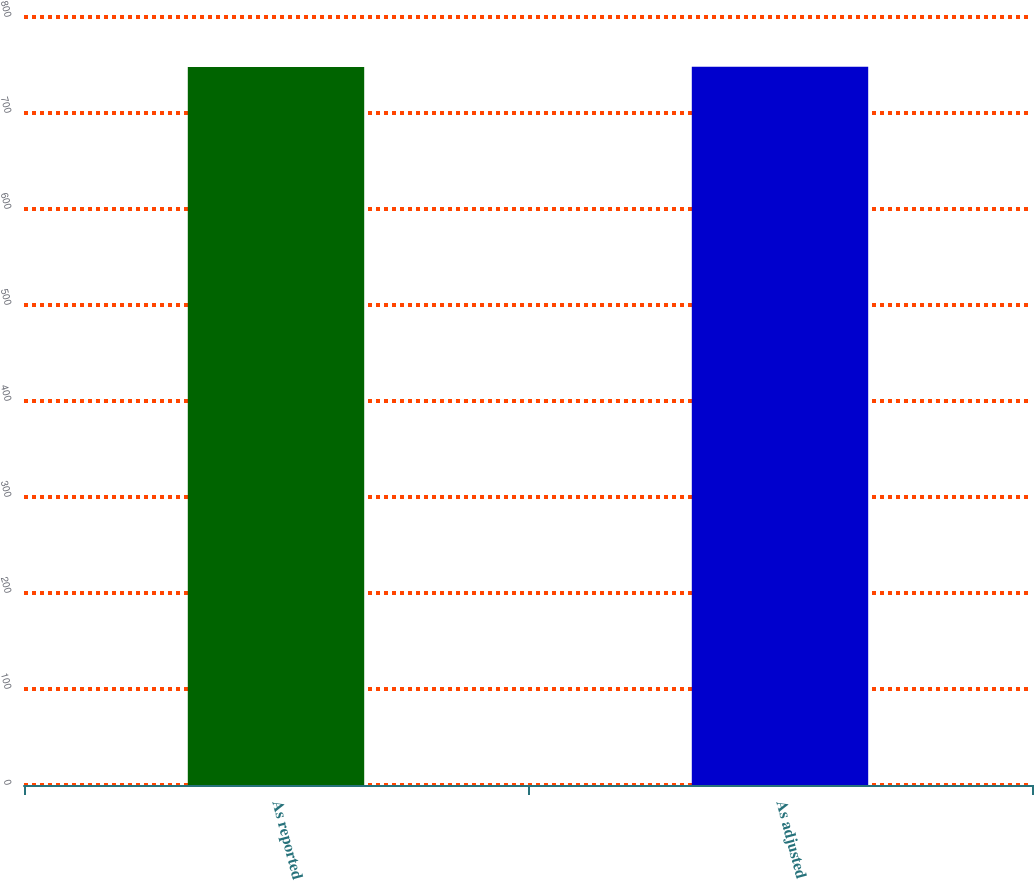Convert chart to OTSL. <chart><loc_0><loc_0><loc_500><loc_500><bar_chart><fcel>As reported<fcel>As adjusted<nl><fcel>748<fcel>748.1<nl></chart> 